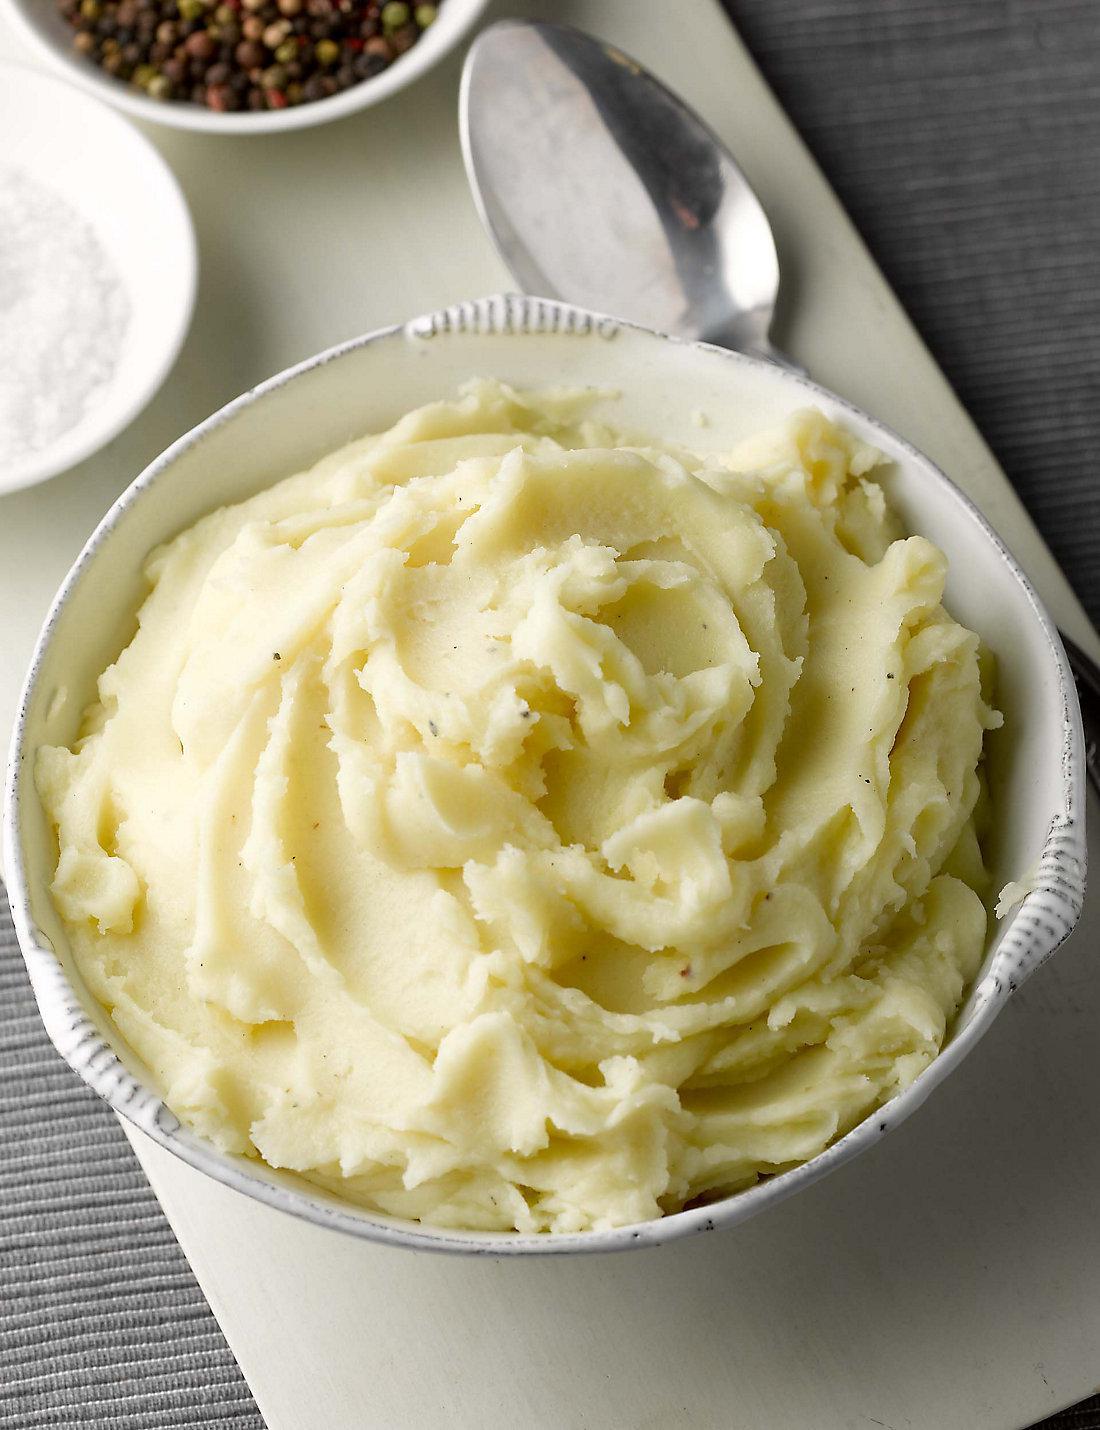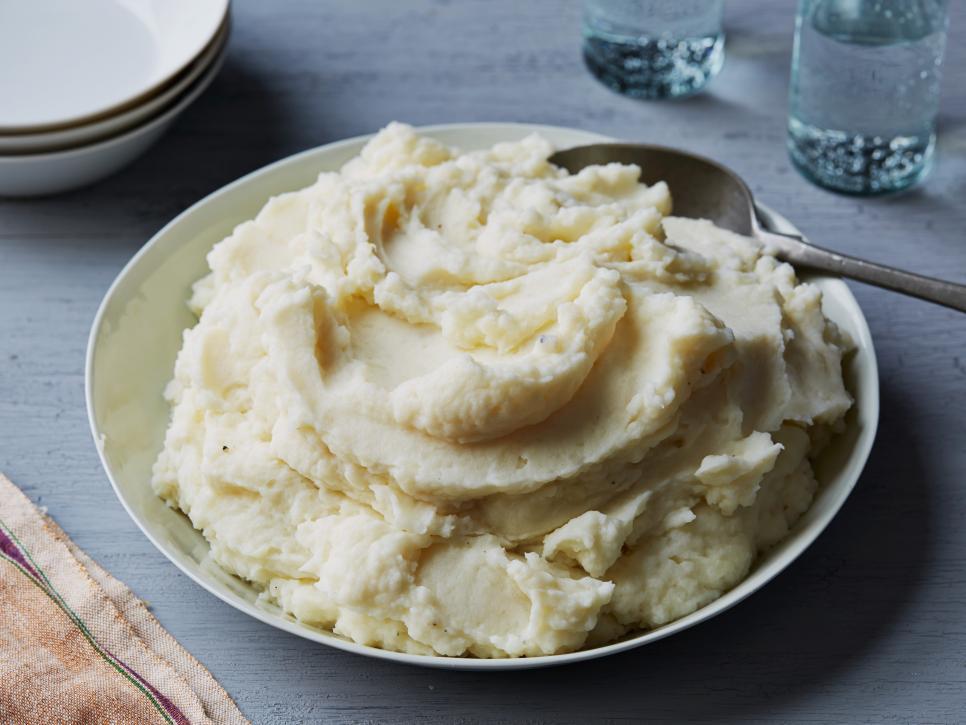The first image is the image on the left, the second image is the image on the right. Evaluate the accuracy of this statement regarding the images: "There is a silver spoon near the bowl of food in the image on the left.". Is it true? Answer yes or no. Yes. The first image is the image on the left, the second image is the image on the right. Given the left and right images, does the statement "Left image shows a silver spoon next to a bowl of mashed potatoes." hold true? Answer yes or no. Yes. 